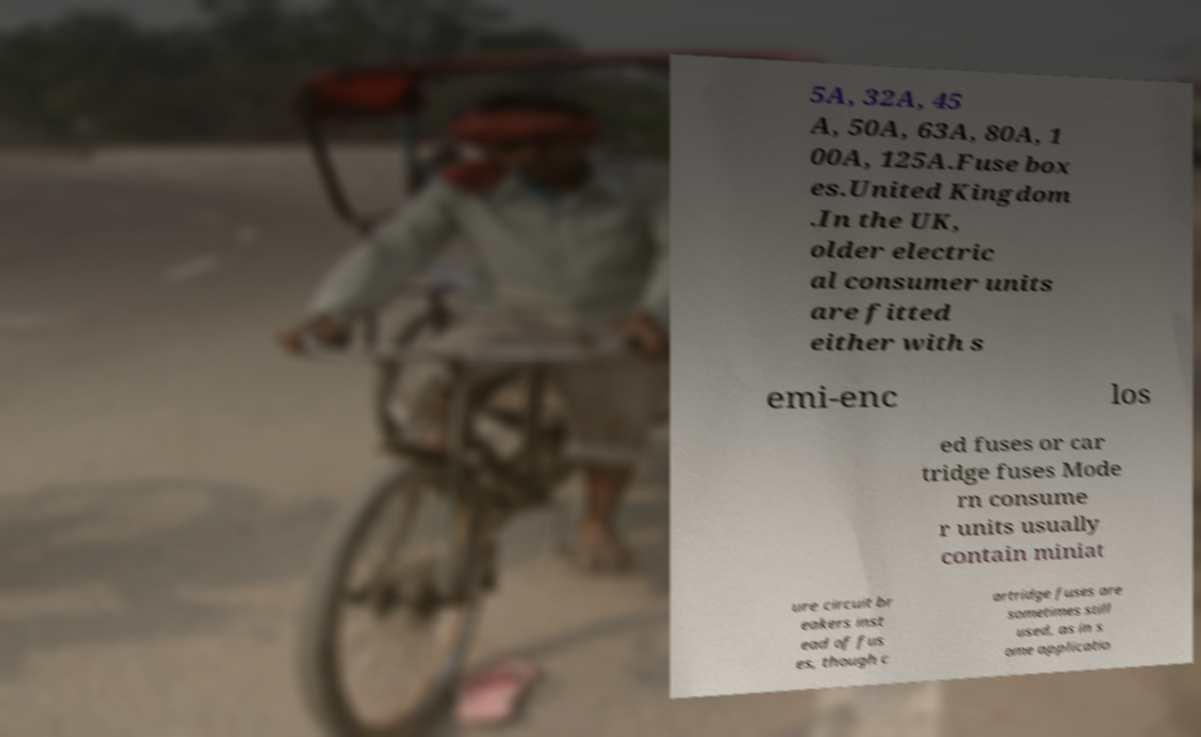For documentation purposes, I need the text within this image transcribed. Could you provide that? 5A, 32A, 45 A, 50A, 63A, 80A, 1 00A, 125A.Fuse box es.United Kingdom .In the UK, older electric al consumer units are fitted either with s emi-enc los ed fuses or car tridge fuses Mode rn consume r units usually contain miniat ure circuit br eakers inst ead of fus es, though c artridge fuses are sometimes still used, as in s ome applicatio 